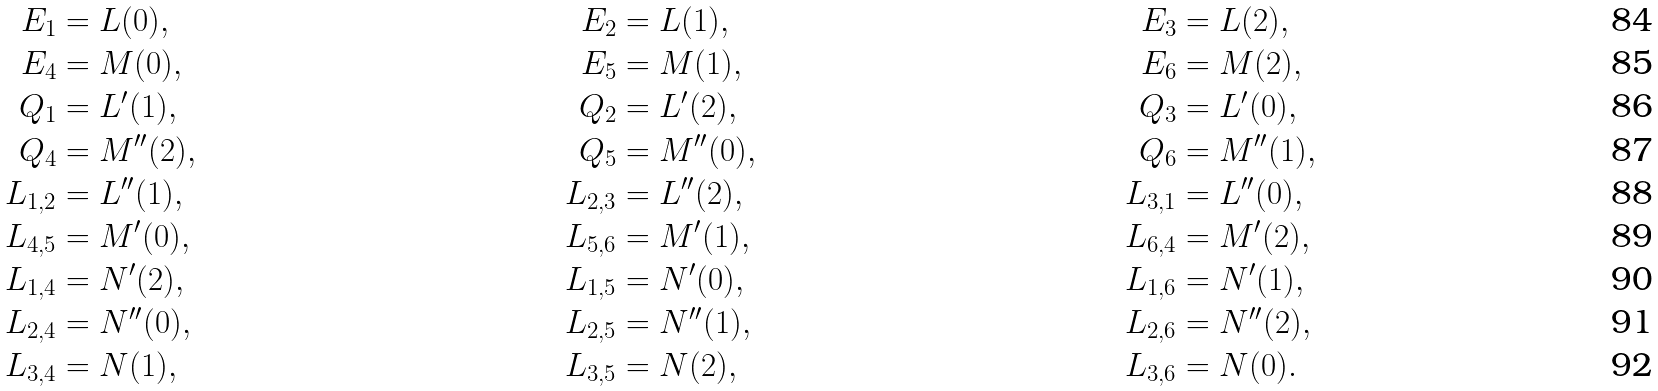Convert formula to latex. <formula><loc_0><loc_0><loc_500><loc_500>E _ { 1 } & = L ( 0 ) , & E _ { 2 } & = L ( 1 ) , & E _ { 3 } & = L ( 2 ) , \\ E _ { 4 } & = M ( 0 ) , & E _ { 5 } & = M ( 1 ) , & E _ { 6 } & = M ( 2 ) , \\ Q _ { 1 } & = L ^ { \prime } ( 1 ) , & Q _ { 2 } & = L ^ { \prime } ( 2 ) , & Q _ { 3 } & = L ^ { \prime } ( 0 ) , \\ Q _ { 4 } & = M ^ { \prime \prime } ( 2 ) , \quad & Q _ { 5 } & = M ^ { \prime \prime } ( 0 ) , \quad & Q _ { 6 } & = M ^ { \prime \prime } ( 1 ) , \\ L _ { 1 , 2 } & = L ^ { \prime \prime } ( 1 ) , & L _ { 2 , 3 } & = L ^ { \prime \prime } ( 2 ) , & L _ { 3 , 1 } & = L ^ { \prime \prime } ( 0 ) , \\ L _ { 4 , 5 } & = M ^ { \prime } ( 0 ) , & L _ { 5 , 6 } & = M ^ { \prime } ( 1 ) , & L _ { 6 , 4 } & = M ^ { \prime } ( 2 ) , \\ L _ { 1 , 4 } & = N ^ { \prime } ( 2 ) , & L _ { 1 , 5 } & = N ^ { \prime } ( 0 ) , & L _ { 1 , 6 } & = N ^ { \prime } ( 1 ) , \\ L _ { 2 , 4 } & = N ^ { \prime \prime } ( 0 ) , & L _ { 2 , 5 } & = N ^ { \prime \prime } ( 1 ) , & L _ { 2 , 6 } & = N ^ { \prime \prime } ( 2 ) , \\ L _ { 3 , 4 } & = N ( 1 ) , & L _ { 3 , 5 } & = N ( 2 ) , & L _ { 3 , 6 } & = N ( 0 ) .</formula> 